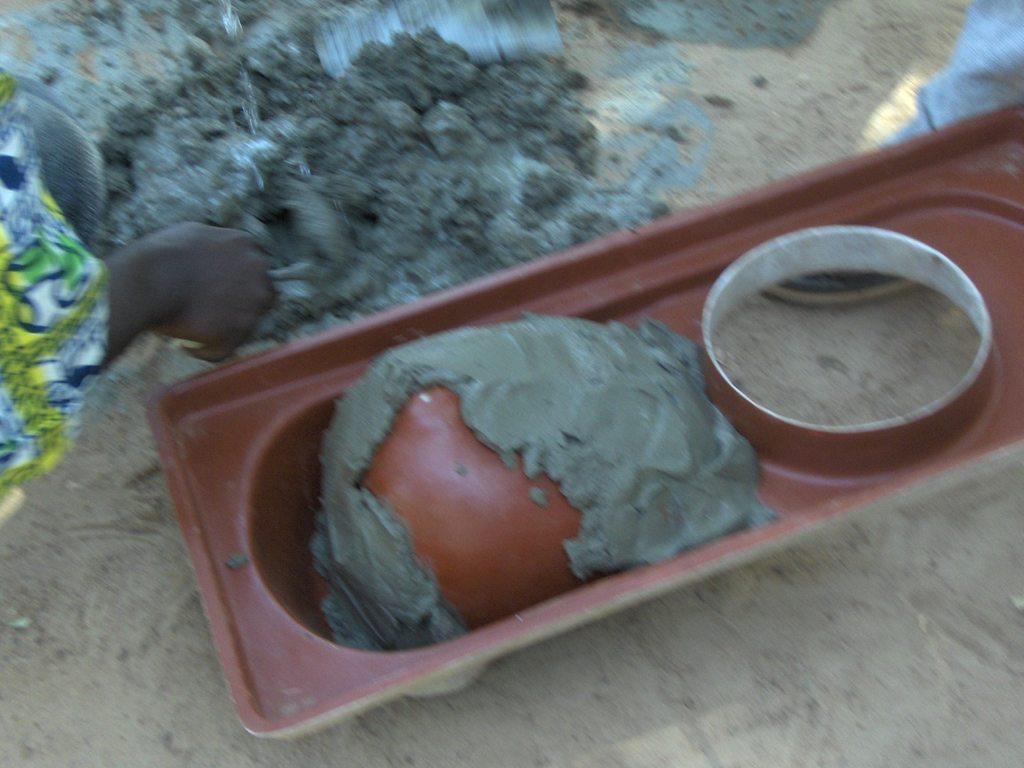How would you summarize this image in a sentence or two? In the image there is a box with concrete in it. On the left side of the image there is a hand of a person. And also there is concrete on the ground. 